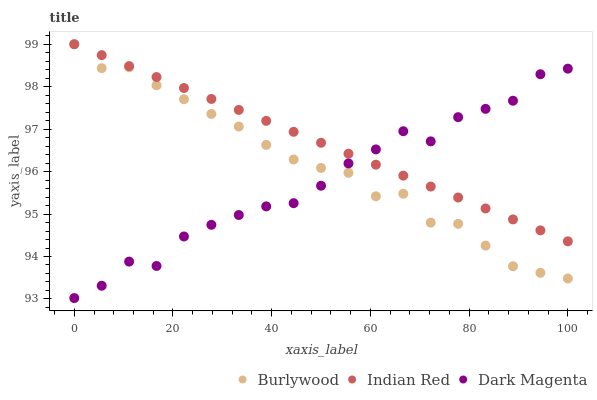Does Dark Magenta have the minimum area under the curve?
Answer yes or no. Yes. Does Indian Red have the maximum area under the curve?
Answer yes or no. Yes. Does Indian Red have the minimum area under the curve?
Answer yes or no. No. Does Dark Magenta have the maximum area under the curve?
Answer yes or no. No. Is Indian Red the smoothest?
Answer yes or no. Yes. Is Dark Magenta the roughest?
Answer yes or no. Yes. Is Dark Magenta the smoothest?
Answer yes or no. No. Is Indian Red the roughest?
Answer yes or no. No. Does Dark Magenta have the lowest value?
Answer yes or no. Yes. Does Indian Red have the lowest value?
Answer yes or no. No. Does Indian Red have the highest value?
Answer yes or no. Yes. Does Dark Magenta have the highest value?
Answer yes or no. No. Does Dark Magenta intersect Indian Red?
Answer yes or no. Yes. Is Dark Magenta less than Indian Red?
Answer yes or no. No. Is Dark Magenta greater than Indian Red?
Answer yes or no. No. 